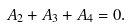Convert formula to latex. <formula><loc_0><loc_0><loc_500><loc_500>A _ { 2 } + A _ { 3 } + A _ { 4 } = 0 .</formula> 